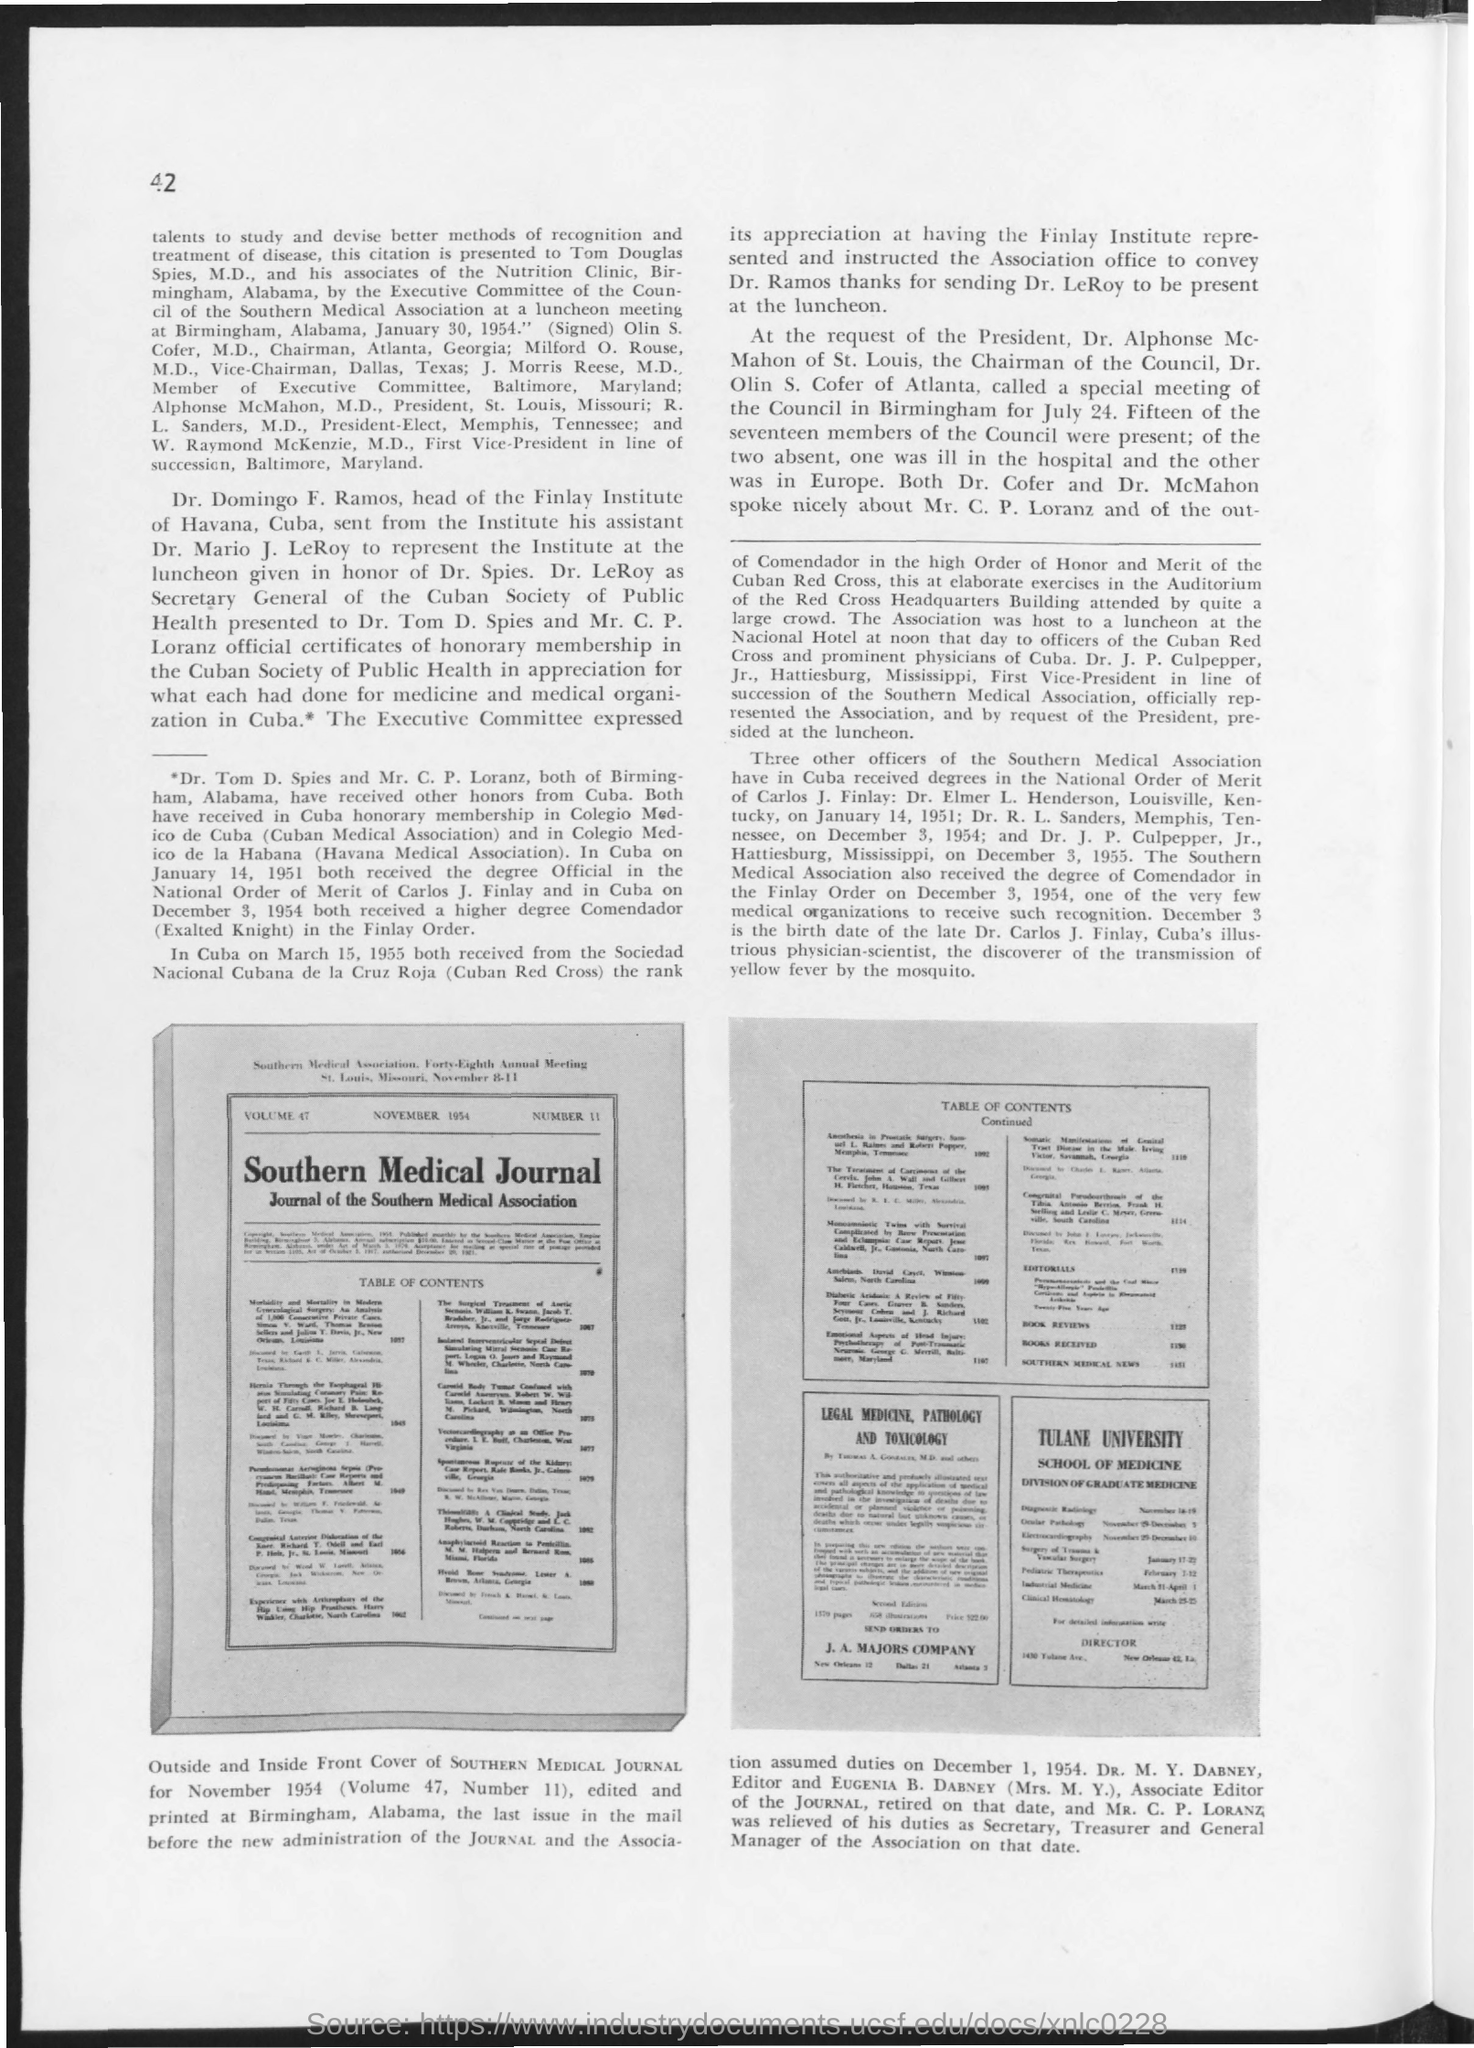What is the page number given at left top corner of the page?
Ensure brevity in your answer.  42. Who is  "head of the Finlay Institute of Havana"?
Provide a succinct answer. Dr. Domingo F. Ramos. Where is "Finlay Institute of Havana" located?
Give a very brief answer. CUBA. Provide the "VOLUME"  number  mentioned in the journal?
Your answer should be compact. 47. Picture of "SOUTHERN MEDICAL JOURNAL" for which month and year  is given?
Your response must be concise. NOVEMBER 1954. Forty-Eighth Annual Meeting of SOUTHERN MEDICAL ASSOCIATION is held at which date?
Your answer should be very brief. NOVEMBER 8-11. Who was the "Editor" of SOUTHERN MEDICAL JOURNAL?
Offer a very short reply. Dr. M.Y. DABNEY. Mention the "birth date of the late Dr. Carlos J. Finlay"?
Offer a terse response. December 3. 